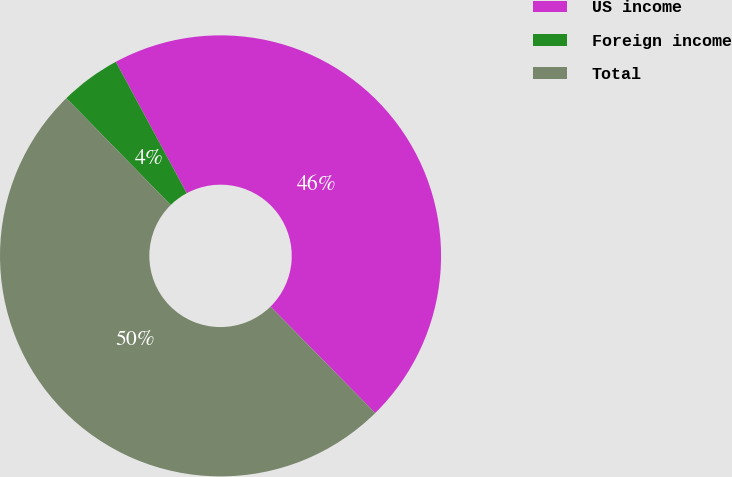<chart> <loc_0><loc_0><loc_500><loc_500><pie_chart><fcel>US income<fcel>Foreign income<fcel>Total<nl><fcel>45.5%<fcel>4.45%<fcel>50.05%<nl></chart> 